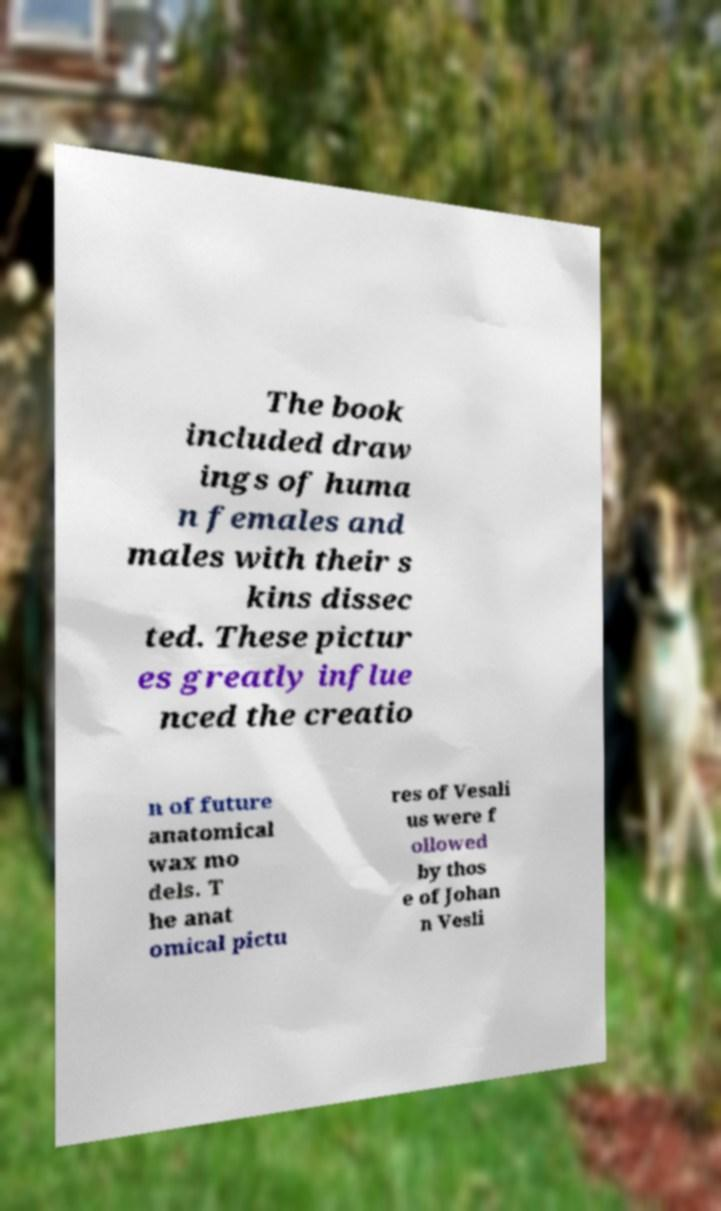Can you read and provide the text displayed in the image?This photo seems to have some interesting text. Can you extract and type it out for me? The book included draw ings of huma n females and males with their s kins dissec ted. These pictur es greatly influe nced the creatio n of future anatomical wax mo dels. T he anat omical pictu res of Vesali us were f ollowed by thos e of Johan n Vesli 